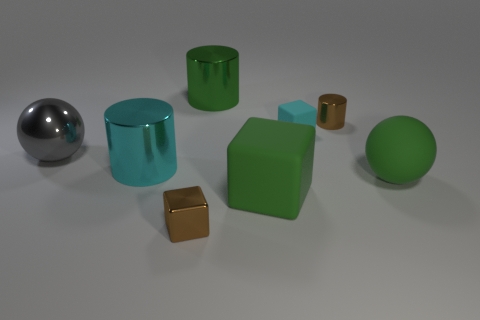What is the big green thing that is both in front of the metallic sphere and behind the big green matte block made of?
Offer a terse response. Rubber. The green ball has what size?
Provide a succinct answer. Large. There is a large sphere left of the large metallic cylinder on the right side of the brown block; how many cyan objects are in front of it?
Provide a short and direct response. 1. What is the shape of the tiny metallic thing that is behind the rubber ball to the right of the gray metallic ball?
Offer a terse response. Cylinder. The rubber object that is the same shape as the gray shiny object is what size?
Your answer should be very brief. Large. Is there anything else that is the same size as the cyan shiny cylinder?
Offer a very short reply. Yes. There is a matte cube that is behind the cyan metal cylinder; what is its color?
Your answer should be compact. Cyan. There is a tiny brown thing behind the brown object that is in front of the gray object that is behind the small brown block; what is its material?
Offer a terse response. Metal. There is a sphere that is on the right side of the tiny brown metal thing in front of the small cyan object; what size is it?
Offer a terse response. Large. What is the color of the other large thing that is the same shape as the cyan shiny thing?
Provide a short and direct response. Green. 